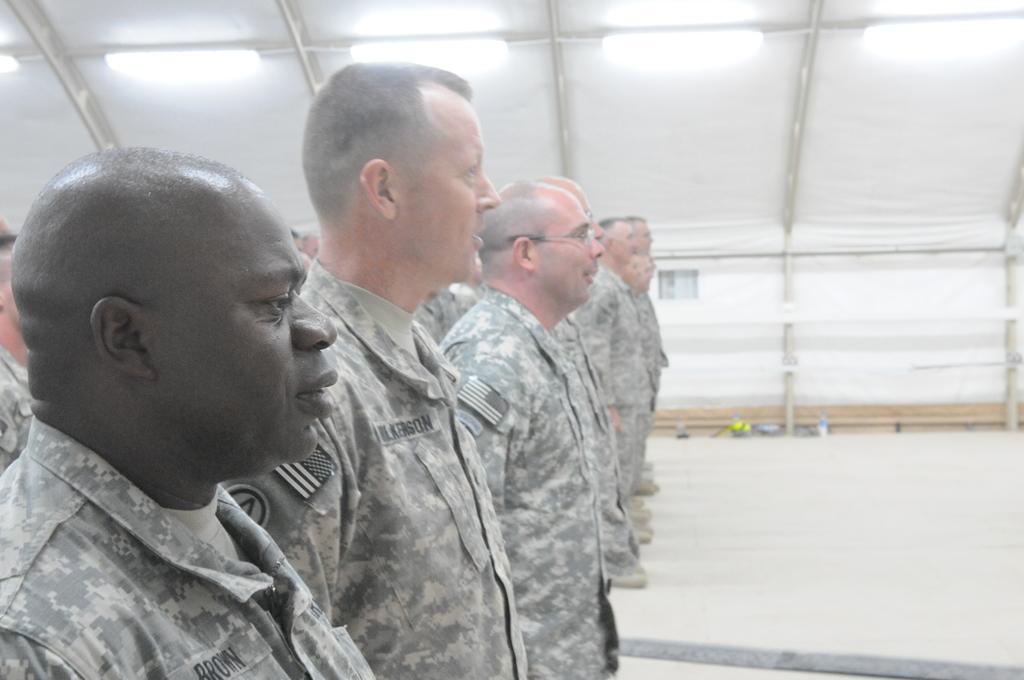How would you summarize this image in a sentence or two? On the left side of this image I can see few men are wearing uniform, standing and facing towards the right side. In the background, I can see a white color tint. 